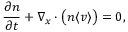<formula> <loc_0><loc_0><loc_500><loc_500>\frac { \partial n } { \partial t } + \nabla _ { x } \cdot \left ( n \langle v \rangle \right ) = 0 ,</formula> 